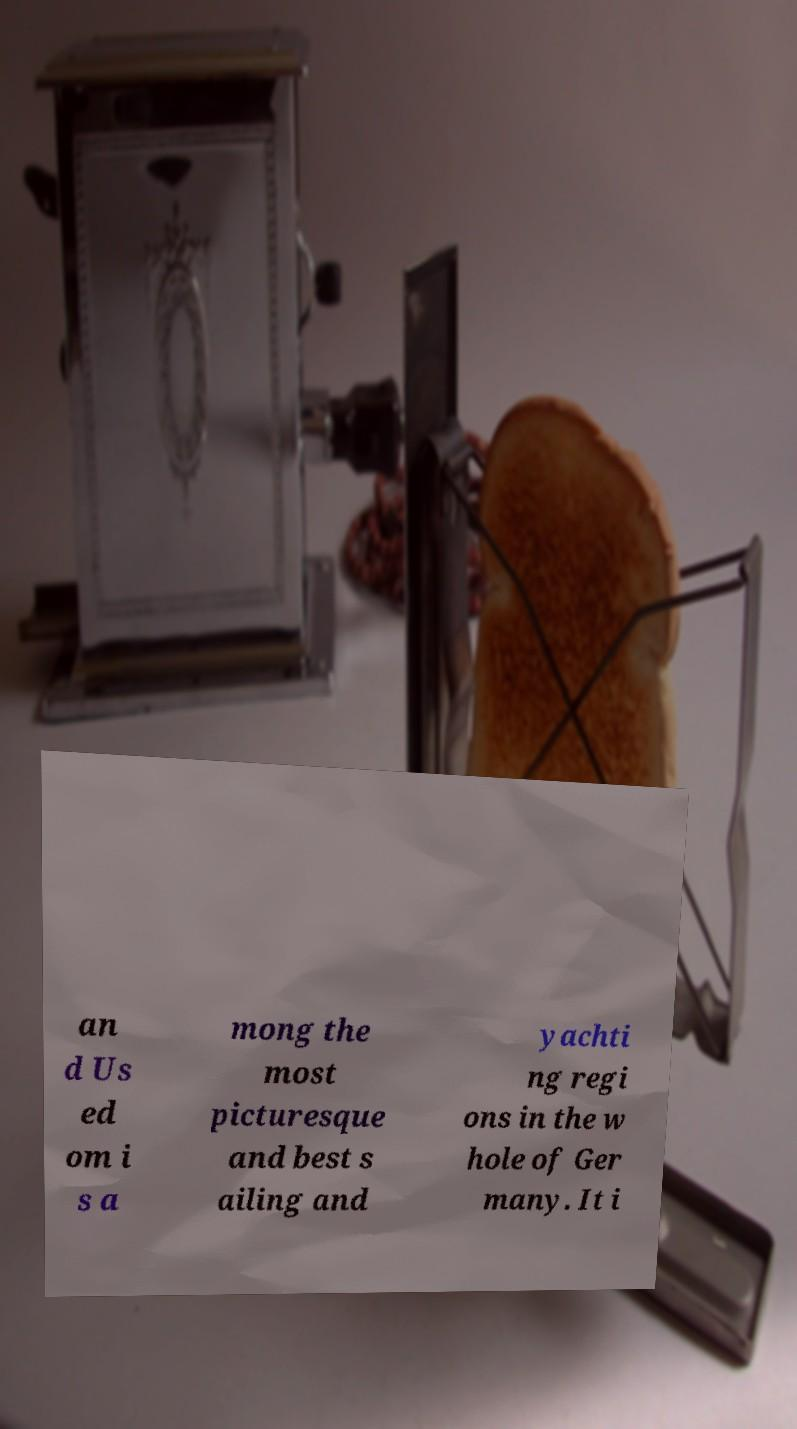I need the written content from this picture converted into text. Can you do that? an d Us ed om i s a mong the most picturesque and best s ailing and yachti ng regi ons in the w hole of Ger many. It i 